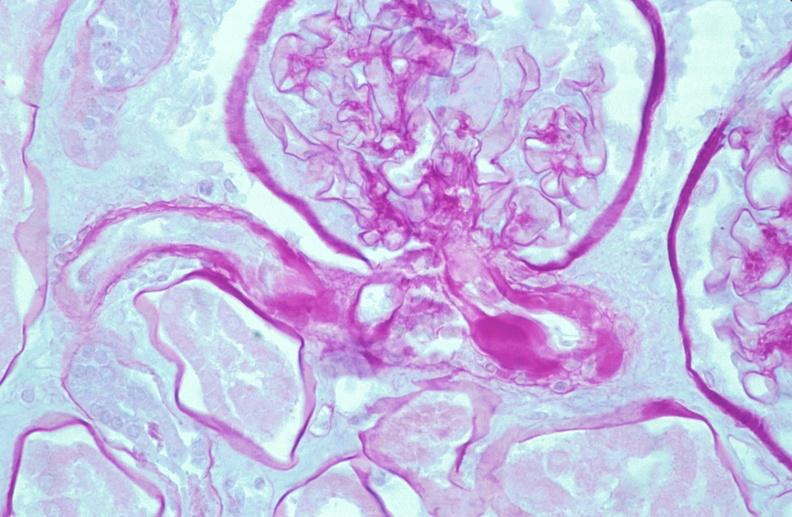does this image show kidney, thickened and hyalinized basement membranes due to diabetes mellitus, pas?
Answer the question using a single word or phrase. Yes 